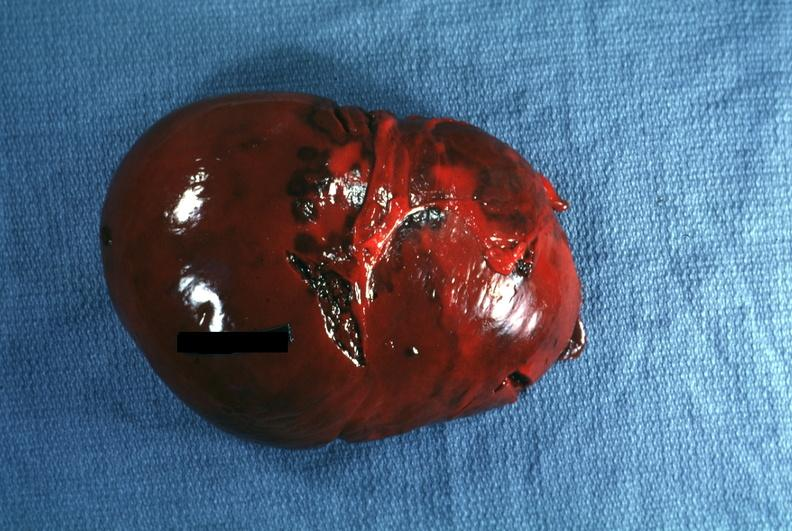s hematologic present?
Answer the question using a single word or phrase. Yes 